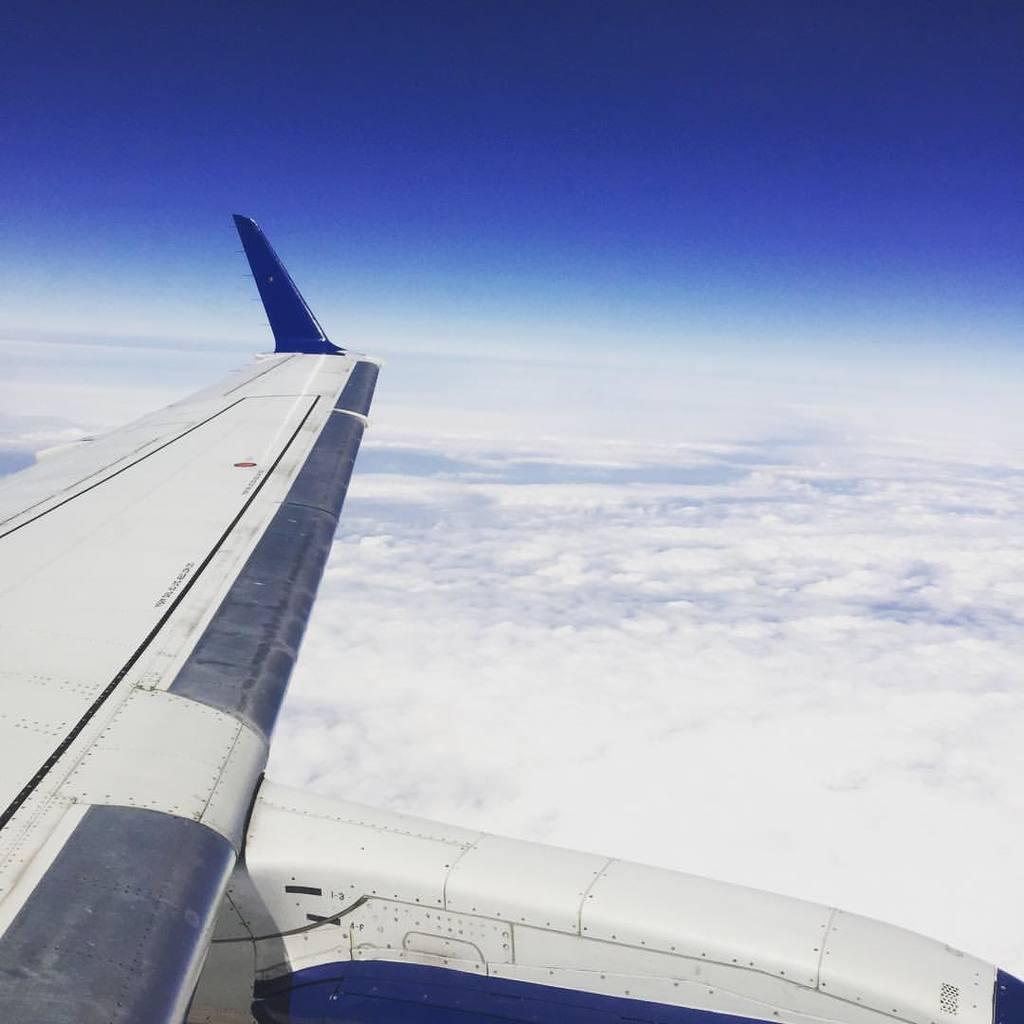What is the main subject of the image? The main subject of the image is a wing of an airplane in the sky. What else can be seen in the sky in the background of the image? Clouds are present in the sky in the background of the image. What type of calendar is hanging on the wing of the airplane in the image? There is no calendar present in the image; it only features a wing of an airplane and clouds in the sky. 